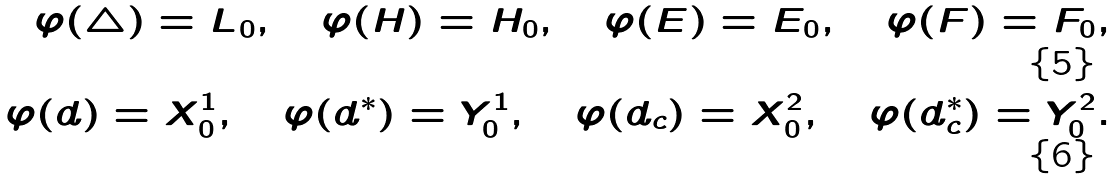Convert formula to latex. <formula><loc_0><loc_0><loc_500><loc_500>\varphi ( \triangle ) = L _ { 0 } , \quad \varphi ( H ) = H _ { 0 } , \quad \varphi ( E ) = E _ { 0 } , \quad \varphi ( F ) = F _ { 0 } , \\ \varphi ( d ) = X _ { 0 } ^ { 1 } , \quad \varphi ( d ^ { * } ) = Y _ { 0 } ^ { 1 } , \quad \varphi ( d _ { c } ) = X _ { 0 } ^ { 2 } , \quad \varphi ( d _ { c } ^ { * } ) = Y _ { 0 } ^ { 2 } .</formula> 